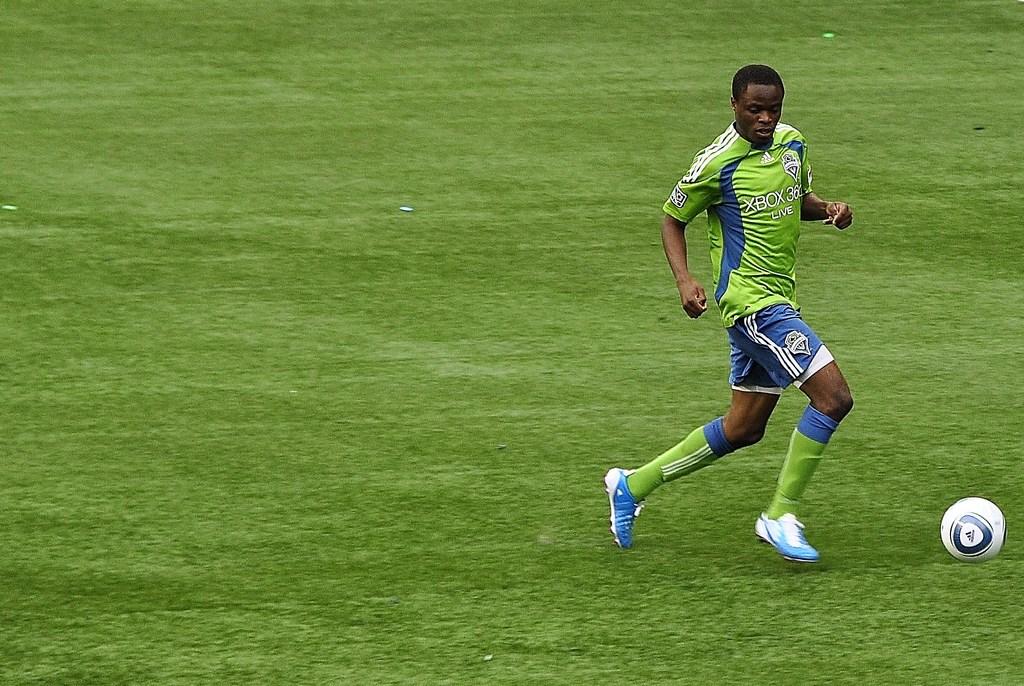Is he wearing an xbox shirt?
Your response must be concise. Yes. 